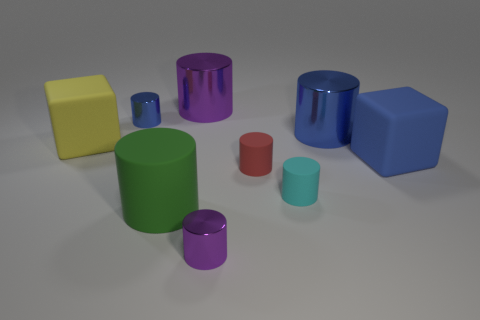Is the shape of the big green object the same as the cyan thing?
Offer a very short reply. Yes. There is a shiny thing in front of the big blue cylinder that is behind the large yellow matte object; what is its shape?
Make the answer very short. Cylinder. Does the cyan rubber thing have the same shape as the blue metal thing on the left side of the green rubber cylinder?
Your answer should be very brief. Yes. There is another matte cube that is the same size as the yellow block; what is its color?
Give a very brief answer. Blue. Are there fewer large purple cylinders that are left of the yellow rubber block than yellow cubes that are in front of the tiny cyan thing?
Provide a succinct answer. No. What is the shape of the metal thing that is left of the large cylinder that is behind the large cylinder that is to the right of the large purple object?
Provide a succinct answer. Cylinder. There is a metal object in front of the blue rubber block; is its color the same as the cube that is left of the tiny purple metallic object?
Your response must be concise. No. What number of matte objects are either big blocks or green objects?
Offer a very short reply. 3. There is a large metallic object to the right of the purple object right of the large metal thing on the left side of the tiny purple shiny thing; what color is it?
Provide a short and direct response. Blue. What color is the other tiny matte object that is the same shape as the red rubber object?
Offer a terse response. Cyan. 